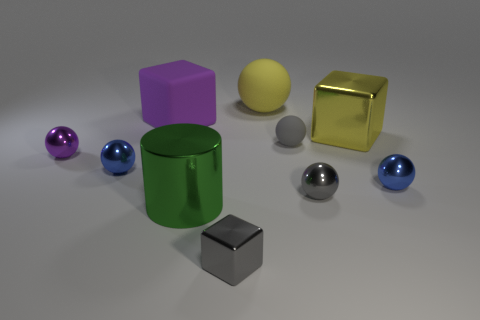Describe the colors and textures present in the objects. The objects in this image display a range of colors and textures. The three spheres have glossy surfaces, with one in purple, another in blue, and the third in gray. The cubes show contrast not only in color, with one being a vibrant yellow and the other a neutral gray, but also in texture, with the yellow cube having a reflective surface and the gray cube appearing matte. The green cylinder adds to the mix with its matte texture akin to the gray cube. The interplay of colors and textures gives this image a sense of diversity and depth.  How does the lighting affect the perception of these objects? The lighting in the image seems to be coming from above, casting subtle shadows beneath the objects, which helps to enhance their three-dimensional form. The glossy surfaces of the spheres and the yellow cube reflect the light more starkly, giving them a vibrant and dynamic quality. In contrast, the matte finish on the green cylinder and gray cube diffuses the light softly, showcasing the textures without reflective glare. The lighting choice accentuates the objects' shapes, colors, and textures, contributing to the overall aesthetic of the scene. 